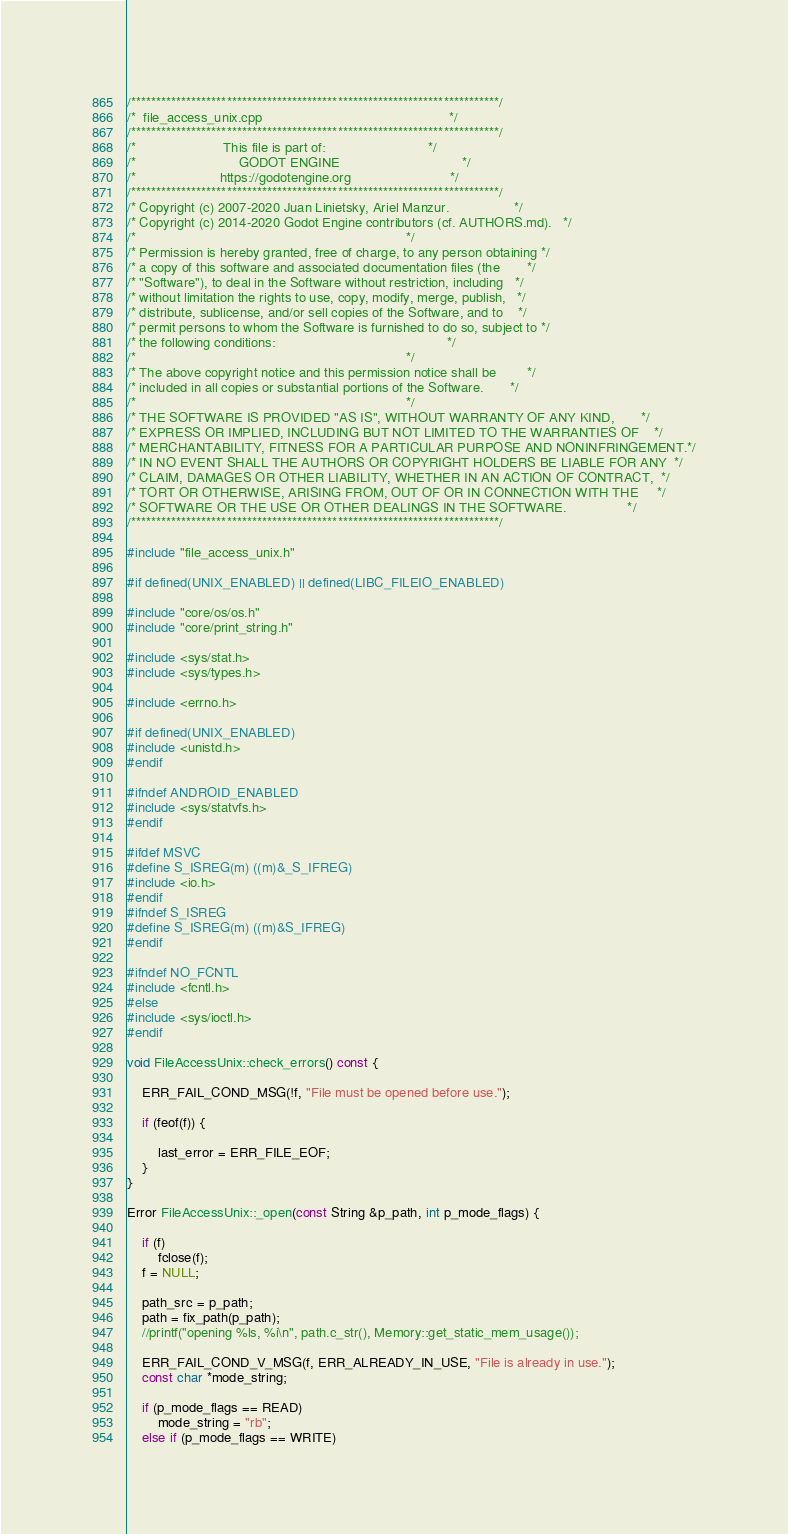Convert code to text. <code><loc_0><loc_0><loc_500><loc_500><_C++_>/*************************************************************************/
/*  file_access_unix.cpp                                                 */
/*************************************************************************/
/*                       This file is part of:                           */
/*                           GODOT ENGINE                                */
/*                      https://godotengine.org                          */
/*************************************************************************/
/* Copyright (c) 2007-2020 Juan Linietsky, Ariel Manzur.                 */
/* Copyright (c) 2014-2020 Godot Engine contributors (cf. AUTHORS.md).   */
/*                                                                       */
/* Permission is hereby granted, free of charge, to any person obtaining */
/* a copy of this software and associated documentation files (the       */
/* "Software"), to deal in the Software without restriction, including   */
/* without limitation the rights to use, copy, modify, merge, publish,   */
/* distribute, sublicense, and/or sell copies of the Software, and to    */
/* permit persons to whom the Software is furnished to do so, subject to */
/* the following conditions:                                             */
/*                                                                       */
/* The above copyright notice and this permission notice shall be        */
/* included in all copies or substantial portions of the Software.       */
/*                                                                       */
/* THE SOFTWARE IS PROVIDED "AS IS", WITHOUT WARRANTY OF ANY KIND,       */
/* EXPRESS OR IMPLIED, INCLUDING BUT NOT LIMITED TO THE WARRANTIES OF    */
/* MERCHANTABILITY, FITNESS FOR A PARTICULAR PURPOSE AND NONINFRINGEMENT.*/
/* IN NO EVENT SHALL THE AUTHORS OR COPYRIGHT HOLDERS BE LIABLE FOR ANY  */
/* CLAIM, DAMAGES OR OTHER LIABILITY, WHETHER IN AN ACTION OF CONTRACT,  */
/* TORT OR OTHERWISE, ARISING FROM, OUT OF OR IN CONNECTION WITH THE     */
/* SOFTWARE OR THE USE OR OTHER DEALINGS IN THE SOFTWARE.                */
/*************************************************************************/

#include "file_access_unix.h"

#if defined(UNIX_ENABLED) || defined(LIBC_FILEIO_ENABLED)

#include "core/os/os.h"
#include "core/print_string.h"

#include <sys/stat.h>
#include <sys/types.h>

#include <errno.h>

#if defined(UNIX_ENABLED)
#include <unistd.h>
#endif

#ifndef ANDROID_ENABLED
#include <sys/statvfs.h>
#endif

#ifdef MSVC
#define S_ISREG(m) ((m)&_S_IFREG)
#include <io.h>
#endif
#ifndef S_ISREG
#define S_ISREG(m) ((m)&S_IFREG)
#endif

#ifndef NO_FCNTL
#include <fcntl.h>
#else
#include <sys/ioctl.h>
#endif

void FileAccessUnix::check_errors() const {

	ERR_FAIL_COND_MSG(!f, "File must be opened before use.");

	if (feof(f)) {

		last_error = ERR_FILE_EOF;
	}
}

Error FileAccessUnix::_open(const String &p_path, int p_mode_flags) {

	if (f)
		fclose(f);
	f = NULL;

	path_src = p_path;
	path = fix_path(p_path);
	//printf("opening %ls, %i\n", path.c_str(), Memory::get_static_mem_usage());

	ERR_FAIL_COND_V_MSG(f, ERR_ALREADY_IN_USE, "File is already in use.");
	const char *mode_string;

	if (p_mode_flags == READ)
		mode_string = "rb";
	else if (p_mode_flags == WRITE)</code> 